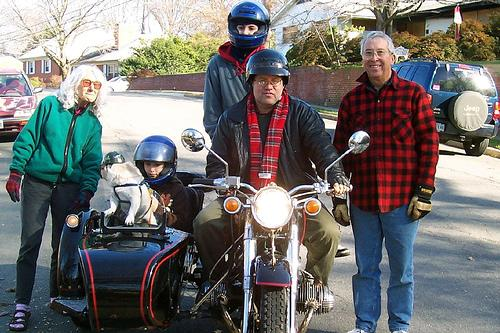What is the little dog wearing in the sidecar? Please explain your reasoning. helmet. This is to protect its head in a crash 